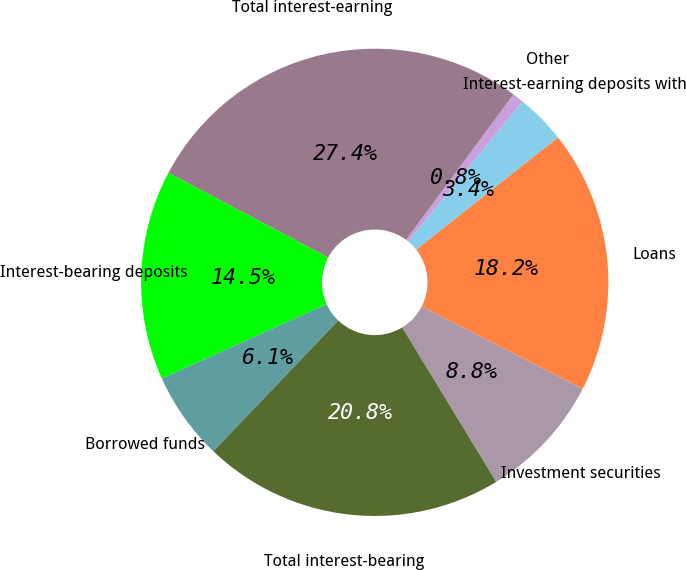Convert chart to OTSL. <chart><loc_0><loc_0><loc_500><loc_500><pie_chart><fcel>Investment securities<fcel>Loans<fcel>Interest-earning deposits with<fcel>Other<fcel>Total interest-earning<fcel>Interest-bearing deposits<fcel>Borrowed funds<fcel>Total interest-bearing<nl><fcel>8.76%<fcel>18.19%<fcel>3.44%<fcel>0.79%<fcel>27.35%<fcel>14.52%<fcel>6.1%<fcel>20.84%<nl></chart> 